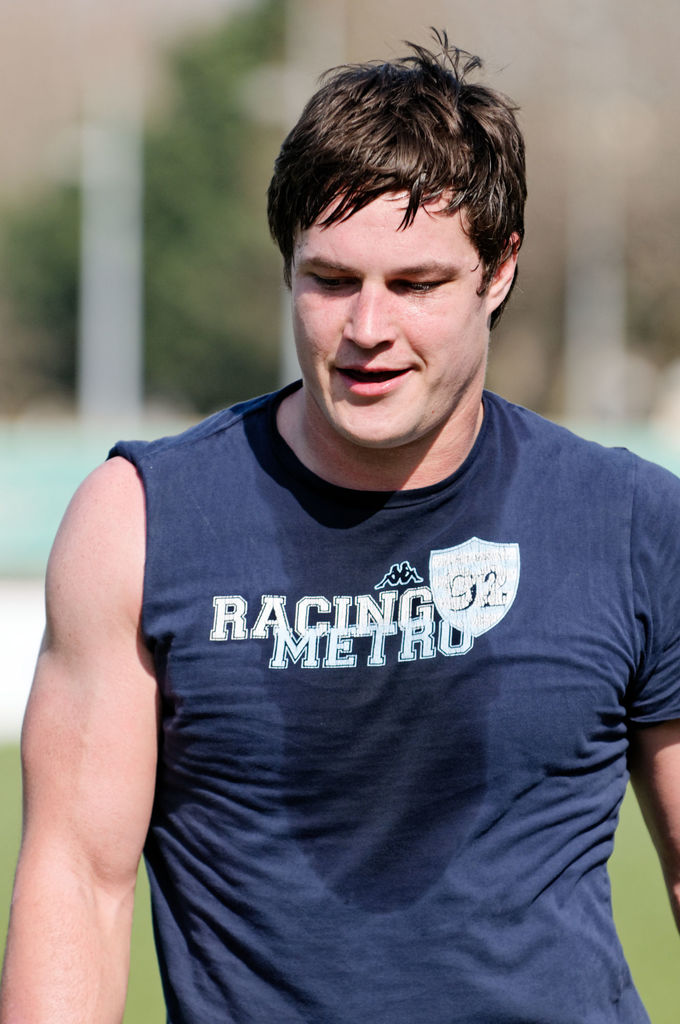Can you comment on the weather conditions in which this photo was taken? The bright sunlight and shadows suggest it's a sunny day, which might contribute to the person's sweaty appearance, indicating a warm and possibly strenuous outdoor activity. 